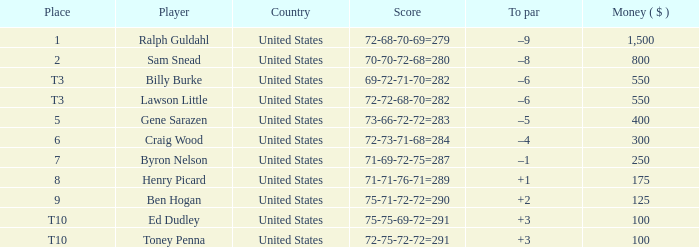Which to par has a prize less than $800? –8. 